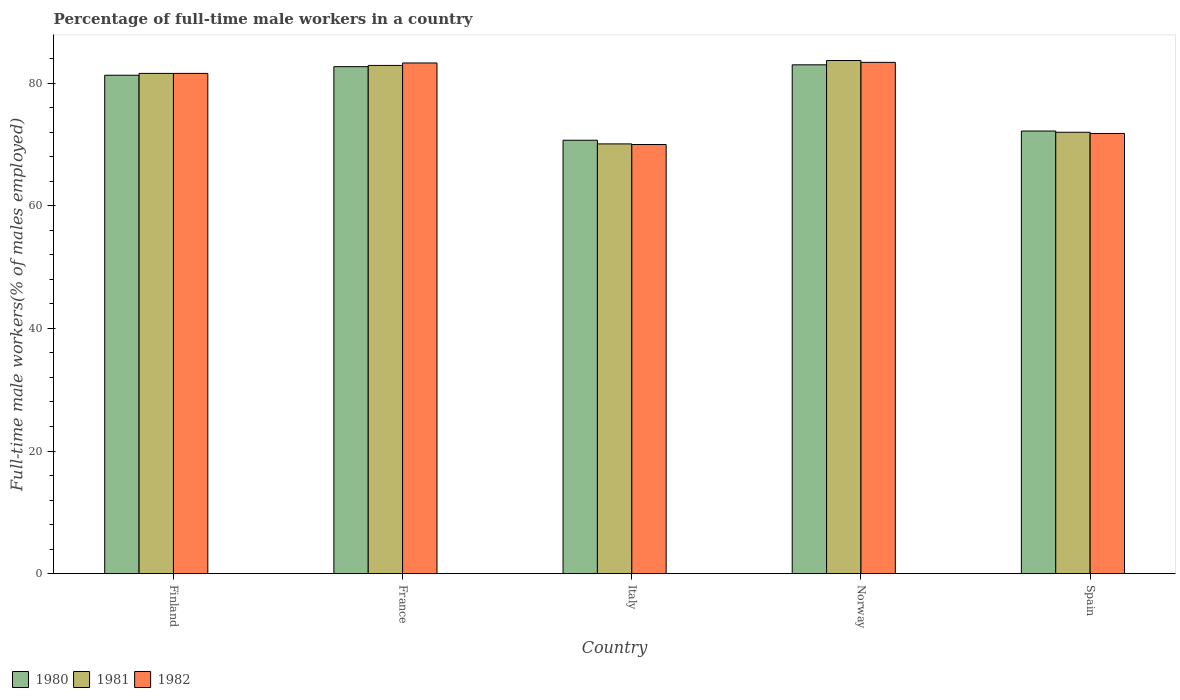How many different coloured bars are there?
Provide a short and direct response. 3. Are the number of bars per tick equal to the number of legend labels?
Offer a very short reply. Yes. How many bars are there on the 2nd tick from the right?
Provide a succinct answer. 3. What is the percentage of full-time male workers in 1981 in Spain?
Your response must be concise. 72. Across all countries, what is the maximum percentage of full-time male workers in 1982?
Provide a succinct answer. 83.4. In which country was the percentage of full-time male workers in 1981 maximum?
Your answer should be compact. Norway. What is the total percentage of full-time male workers in 1980 in the graph?
Give a very brief answer. 389.9. What is the difference between the percentage of full-time male workers in 1981 in Italy and that in Spain?
Make the answer very short. -1.9. What is the average percentage of full-time male workers in 1980 per country?
Provide a succinct answer. 77.98. What is the difference between the percentage of full-time male workers of/in 1980 and percentage of full-time male workers of/in 1981 in Norway?
Your response must be concise. -0.7. What is the ratio of the percentage of full-time male workers in 1982 in Finland to that in Spain?
Give a very brief answer. 1.14. Is the percentage of full-time male workers in 1981 in France less than that in Spain?
Ensure brevity in your answer.  No. Is the difference between the percentage of full-time male workers in 1980 in Finland and Norway greater than the difference between the percentage of full-time male workers in 1981 in Finland and Norway?
Provide a short and direct response. Yes. What is the difference between the highest and the second highest percentage of full-time male workers in 1980?
Your response must be concise. -1.4. What is the difference between the highest and the lowest percentage of full-time male workers in 1982?
Ensure brevity in your answer.  13.4. In how many countries, is the percentage of full-time male workers in 1980 greater than the average percentage of full-time male workers in 1980 taken over all countries?
Provide a succinct answer. 3. Is the sum of the percentage of full-time male workers in 1980 in France and Italy greater than the maximum percentage of full-time male workers in 1981 across all countries?
Provide a short and direct response. Yes. What does the 1st bar from the left in Spain represents?
Offer a terse response. 1980. What does the 3rd bar from the right in Finland represents?
Make the answer very short. 1980. How many bars are there?
Offer a terse response. 15. How many countries are there in the graph?
Offer a terse response. 5. What is the difference between two consecutive major ticks on the Y-axis?
Ensure brevity in your answer.  20. Are the values on the major ticks of Y-axis written in scientific E-notation?
Offer a very short reply. No. Does the graph contain grids?
Your answer should be compact. No. How are the legend labels stacked?
Ensure brevity in your answer.  Horizontal. What is the title of the graph?
Keep it short and to the point. Percentage of full-time male workers in a country. Does "1963" appear as one of the legend labels in the graph?
Your answer should be very brief. No. What is the label or title of the Y-axis?
Your response must be concise. Full-time male workers(% of males employed). What is the Full-time male workers(% of males employed) in 1980 in Finland?
Keep it short and to the point. 81.3. What is the Full-time male workers(% of males employed) in 1981 in Finland?
Ensure brevity in your answer.  81.6. What is the Full-time male workers(% of males employed) in 1982 in Finland?
Your answer should be compact. 81.6. What is the Full-time male workers(% of males employed) of 1980 in France?
Keep it short and to the point. 82.7. What is the Full-time male workers(% of males employed) of 1981 in France?
Ensure brevity in your answer.  82.9. What is the Full-time male workers(% of males employed) in 1982 in France?
Your answer should be compact. 83.3. What is the Full-time male workers(% of males employed) in 1980 in Italy?
Make the answer very short. 70.7. What is the Full-time male workers(% of males employed) in 1981 in Italy?
Ensure brevity in your answer.  70.1. What is the Full-time male workers(% of males employed) of 1982 in Italy?
Offer a very short reply. 70. What is the Full-time male workers(% of males employed) in 1981 in Norway?
Provide a short and direct response. 83.7. What is the Full-time male workers(% of males employed) of 1982 in Norway?
Provide a short and direct response. 83.4. What is the Full-time male workers(% of males employed) in 1980 in Spain?
Your answer should be compact. 72.2. What is the Full-time male workers(% of males employed) in 1982 in Spain?
Ensure brevity in your answer.  71.8. Across all countries, what is the maximum Full-time male workers(% of males employed) in 1981?
Ensure brevity in your answer.  83.7. Across all countries, what is the maximum Full-time male workers(% of males employed) of 1982?
Ensure brevity in your answer.  83.4. Across all countries, what is the minimum Full-time male workers(% of males employed) in 1980?
Offer a terse response. 70.7. Across all countries, what is the minimum Full-time male workers(% of males employed) in 1981?
Your answer should be compact. 70.1. Across all countries, what is the minimum Full-time male workers(% of males employed) in 1982?
Provide a short and direct response. 70. What is the total Full-time male workers(% of males employed) in 1980 in the graph?
Offer a terse response. 389.9. What is the total Full-time male workers(% of males employed) of 1981 in the graph?
Keep it short and to the point. 390.3. What is the total Full-time male workers(% of males employed) of 1982 in the graph?
Ensure brevity in your answer.  390.1. What is the difference between the Full-time male workers(% of males employed) in 1981 in Finland and that in France?
Offer a very short reply. -1.3. What is the difference between the Full-time male workers(% of males employed) in 1982 in Finland and that in Italy?
Your response must be concise. 11.6. What is the difference between the Full-time male workers(% of males employed) in 1980 in Finland and that in Norway?
Offer a terse response. -1.7. What is the difference between the Full-time male workers(% of males employed) in 1981 in Finland and that in Norway?
Your response must be concise. -2.1. What is the difference between the Full-time male workers(% of males employed) in 1980 in Finland and that in Spain?
Your answer should be compact. 9.1. What is the difference between the Full-time male workers(% of males employed) in 1981 in Finland and that in Spain?
Offer a very short reply. 9.6. What is the difference between the Full-time male workers(% of males employed) in 1982 in Finland and that in Spain?
Your answer should be very brief. 9.8. What is the difference between the Full-time male workers(% of males employed) in 1981 in France and that in Italy?
Ensure brevity in your answer.  12.8. What is the difference between the Full-time male workers(% of males employed) in 1980 in France and that in Norway?
Offer a terse response. -0.3. What is the difference between the Full-time male workers(% of males employed) of 1981 in France and that in Norway?
Your response must be concise. -0.8. What is the difference between the Full-time male workers(% of males employed) of 1982 in France and that in Norway?
Your response must be concise. -0.1. What is the difference between the Full-time male workers(% of males employed) in 1982 in France and that in Spain?
Offer a terse response. 11.5. What is the difference between the Full-time male workers(% of males employed) in 1980 in Italy and that in Norway?
Your answer should be very brief. -12.3. What is the difference between the Full-time male workers(% of males employed) in 1981 in Italy and that in Norway?
Your answer should be compact. -13.6. What is the difference between the Full-time male workers(% of males employed) of 1980 in Italy and that in Spain?
Provide a short and direct response. -1.5. What is the difference between the Full-time male workers(% of males employed) of 1981 in Italy and that in Spain?
Keep it short and to the point. -1.9. What is the difference between the Full-time male workers(% of males employed) of 1980 in Finland and the Full-time male workers(% of males employed) of 1981 in France?
Provide a short and direct response. -1.6. What is the difference between the Full-time male workers(% of males employed) in 1980 in Finland and the Full-time male workers(% of males employed) in 1981 in Norway?
Your answer should be very brief. -2.4. What is the difference between the Full-time male workers(% of males employed) in 1980 in Finland and the Full-time male workers(% of males employed) in 1982 in Norway?
Make the answer very short. -2.1. What is the difference between the Full-time male workers(% of males employed) of 1981 in Finland and the Full-time male workers(% of males employed) of 1982 in Norway?
Provide a short and direct response. -1.8. What is the difference between the Full-time male workers(% of males employed) in 1980 in France and the Full-time male workers(% of males employed) in 1981 in Italy?
Provide a succinct answer. 12.6. What is the difference between the Full-time male workers(% of males employed) of 1980 in France and the Full-time male workers(% of males employed) of 1982 in Italy?
Your answer should be very brief. 12.7. What is the difference between the Full-time male workers(% of males employed) in 1980 in France and the Full-time male workers(% of males employed) in 1982 in Spain?
Your response must be concise. 10.9. What is the difference between the Full-time male workers(% of males employed) in 1981 in France and the Full-time male workers(% of males employed) in 1982 in Spain?
Offer a terse response. 11.1. What is the difference between the Full-time male workers(% of males employed) of 1980 in Italy and the Full-time male workers(% of males employed) of 1981 in Norway?
Your answer should be compact. -13. What is the difference between the Full-time male workers(% of males employed) in 1981 in Italy and the Full-time male workers(% of males employed) in 1982 in Norway?
Your answer should be very brief. -13.3. What is the difference between the Full-time male workers(% of males employed) of 1980 in Norway and the Full-time male workers(% of males employed) of 1981 in Spain?
Keep it short and to the point. 11. What is the average Full-time male workers(% of males employed) in 1980 per country?
Keep it short and to the point. 77.98. What is the average Full-time male workers(% of males employed) of 1981 per country?
Give a very brief answer. 78.06. What is the average Full-time male workers(% of males employed) in 1982 per country?
Offer a terse response. 78.02. What is the difference between the Full-time male workers(% of males employed) of 1980 and Full-time male workers(% of males employed) of 1981 in Finland?
Your answer should be very brief. -0.3. What is the difference between the Full-time male workers(% of males employed) in 1981 and Full-time male workers(% of males employed) in 1982 in Finland?
Provide a short and direct response. 0. What is the difference between the Full-time male workers(% of males employed) in 1980 and Full-time male workers(% of males employed) in 1982 in France?
Your response must be concise. -0.6. What is the difference between the Full-time male workers(% of males employed) in 1980 and Full-time male workers(% of males employed) in 1981 in Italy?
Keep it short and to the point. 0.6. What is the difference between the Full-time male workers(% of males employed) in 1980 and Full-time male workers(% of males employed) in 1982 in Italy?
Your response must be concise. 0.7. What is the difference between the Full-time male workers(% of males employed) in 1981 and Full-time male workers(% of males employed) in 1982 in Italy?
Keep it short and to the point. 0.1. What is the difference between the Full-time male workers(% of males employed) in 1980 and Full-time male workers(% of males employed) in 1981 in Norway?
Your response must be concise. -0.7. What is the difference between the Full-time male workers(% of males employed) in 1980 and Full-time male workers(% of males employed) in 1982 in Norway?
Give a very brief answer. -0.4. What is the difference between the Full-time male workers(% of males employed) in 1980 and Full-time male workers(% of males employed) in 1981 in Spain?
Ensure brevity in your answer.  0.2. What is the ratio of the Full-time male workers(% of males employed) of 1980 in Finland to that in France?
Provide a succinct answer. 0.98. What is the ratio of the Full-time male workers(% of males employed) in 1981 in Finland to that in France?
Your answer should be very brief. 0.98. What is the ratio of the Full-time male workers(% of males employed) of 1982 in Finland to that in France?
Your answer should be very brief. 0.98. What is the ratio of the Full-time male workers(% of males employed) in 1980 in Finland to that in Italy?
Give a very brief answer. 1.15. What is the ratio of the Full-time male workers(% of males employed) of 1981 in Finland to that in Italy?
Offer a very short reply. 1.16. What is the ratio of the Full-time male workers(% of males employed) in 1982 in Finland to that in Italy?
Your answer should be very brief. 1.17. What is the ratio of the Full-time male workers(% of males employed) in 1980 in Finland to that in Norway?
Your answer should be compact. 0.98. What is the ratio of the Full-time male workers(% of males employed) in 1981 in Finland to that in Norway?
Provide a short and direct response. 0.97. What is the ratio of the Full-time male workers(% of males employed) in 1982 in Finland to that in Norway?
Your answer should be compact. 0.98. What is the ratio of the Full-time male workers(% of males employed) of 1980 in Finland to that in Spain?
Give a very brief answer. 1.13. What is the ratio of the Full-time male workers(% of males employed) of 1981 in Finland to that in Spain?
Your answer should be compact. 1.13. What is the ratio of the Full-time male workers(% of males employed) of 1982 in Finland to that in Spain?
Provide a succinct answer. 1.14. What is the ratio of the Full-time male workers(% of males employed) of 1980 in France to that in Italy?
Provide a short and direct response. 1.17. What is the ratio of the Full-time male workers(% of males employed) in 1981 in France to that in Italy?
Provide a succinct answer. 1.18. What is the ratio of the Full-time male workers(% of males employed) of 1982 in France to that in Italy?
Offer a very short reply. 1.19. What is the ratio of the Full-time male workers(% of males employed) in 1980 in France to that in Spain?
Your answer should be compact. 1.15. What is the ratio of the Full-time male workers(% of males employed) of 1981 in France to that in Spain?
Ensure brevity in your answer.  1.15. What is the ratio of the Full-time male workers(% of males employed) of 1982 in France to that in Spain?
Your answer should be compact. 1.16. What is the ratio of the Full-time male workers(% of males employed) in 1980 in Italy to that in Norway?
Offer a very short reply. 0.85. What is the ratio of the Full-time male workers(% of males employed) in 1981 in Italy to that in Norway?
Offer a very short reply. 0.84. What is the ratio of the Full-time male workers(% of males employed) of 1982 in Italy to that in Norway?
Offer a very short reply. 0.84. What is the ratio of the Full-time male workers(% of males employed) in 1980 in Italy to that in Spain?
Your answer should be compact. 0.98. What is the ratio of the Full-time male workers(% of males employed) in 1981 in Italy to that in Spain?
Offer a very short reply. 0.97. What is the ratio of the Full-time male workers(% of males employed) of 1982 in Italy to that in Spain?
Give a very brief answer. 0.97. What is the ratio of the Full-time male workers(% of males employed) of 1980 in Norway to that in Spain?
Ensure brevity in your answer.  1.15. What is the ratio of the Full-time male workers(% of males employed) of 1981 in Norway to that in Spain?
Provide a short and direct response. 1.16. What is the ratio of the Full-time male workers(% of males employed) of 1982 in Norway to that in Spain?
Make the answer very short. 1.16. What is the difference between the highest and the second highest Full-time male workers(% of males employed) in 1981?
Ensure brevity in your answer.  0.8. What is the difference between the highest and the lowest Full-time male workers(% of males employed) in 1982?
Your answer should be compact. 13.4. 